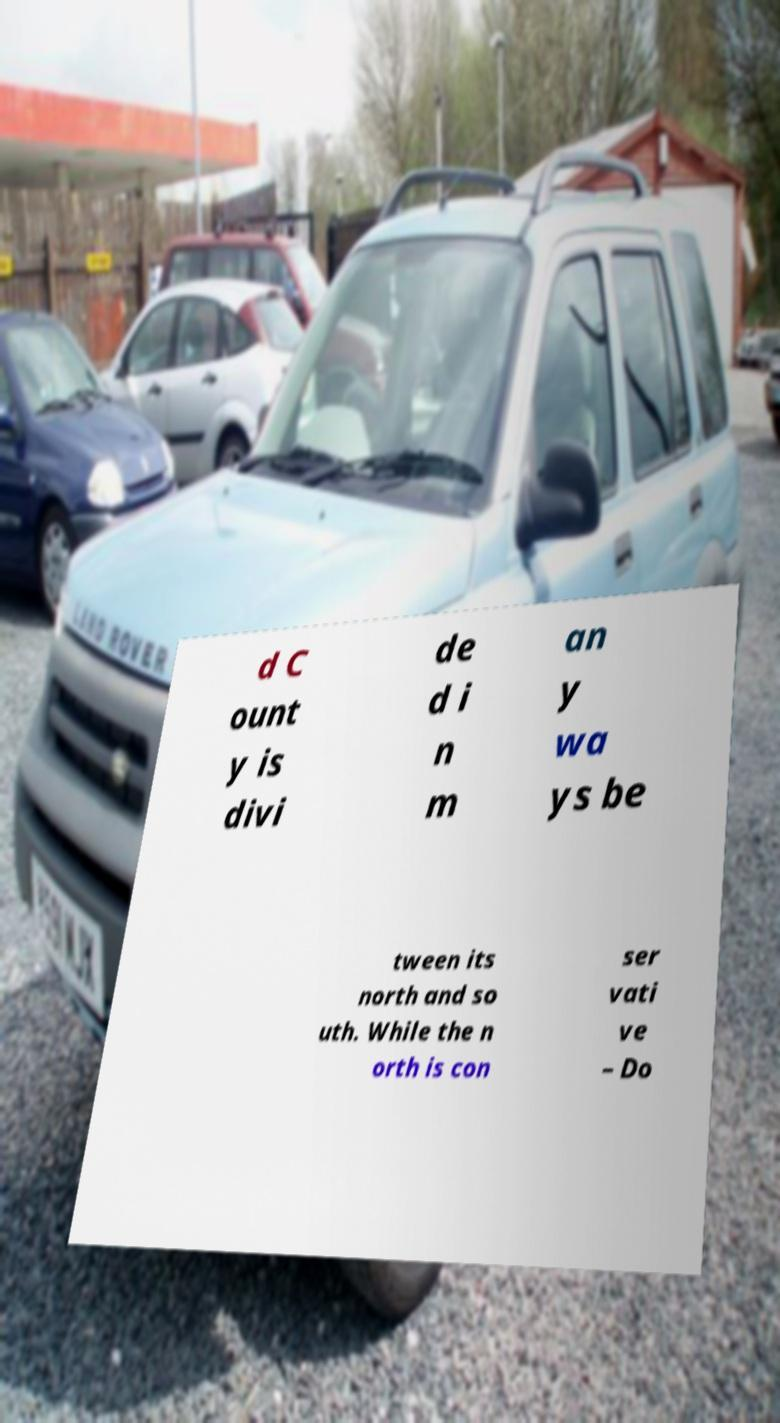I need the written content from this picture converted into text. Can you do that? d C ount y is divi de d i n m an y wa ys be tween its north and so uth. While the n orth is con ser vati ve – Do 